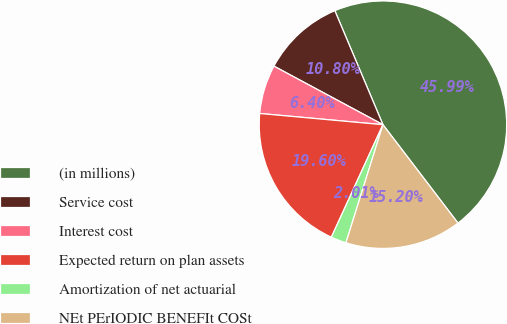Convert chart. <chart><loc_0><loc_0><loc_500><loc_500><pie_chart><fcel>(in millions)<fcel>Service cost<fcel>Interest cost<fcel>Expected return on plan assets<fcel>Amortization of net actuarial<fcel>NEt PErIODIC BENEFIt COSt<nl><fcel>45.99%<fcel>10.8%<fcel>6.4%<fcel>19.6%<fcel>2.01%<fcel>15.2%<nl></chart> 